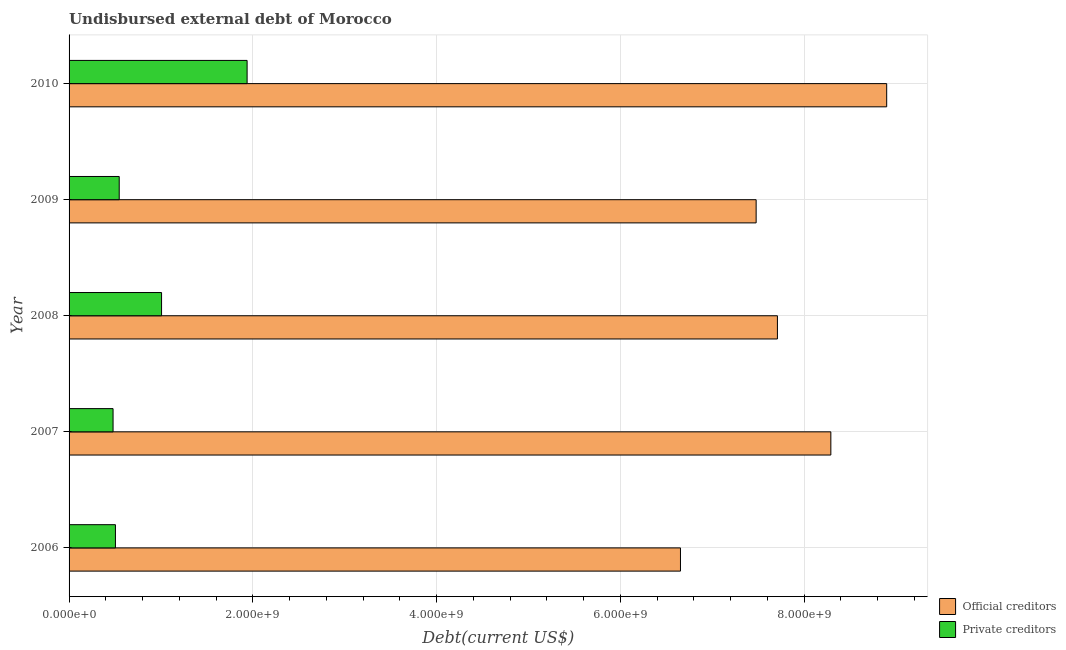Are the number of bars per tick equal to the number of legend labels?
Provide a short and direct response. Yes. How many bars are there on the 3rd tick from the bottom?
Offer a very short reply. 2. What is the label of the 5th group of bars from the top?
Offer a terse response. 2006. What is the undisbursed external debt of private creditors in 2009?
Offer a very short reply. 5.46e+08. Across all years, what is the maximum undisbursed external debt of private creditors?
Ensure brevity in your answer.  1.94e+09. Across all years, what is the minimum undisbursed external debt of private creditors?
Your answer should be very brief. 4.79e+08. In which year was the undisbursed external debt of official creditors maximum?
Offer a very short reply. 2010. In which year was the undisbursed external debt of official creditors minimum?
Give a very brief answer. 2006. What is the total undisbursed external debt of private creditors in the graph?
Keep it short and to the point. 4.47e+09. What is the difference between the undisbursed external debt of official creditors in 2007 and that in 2010?
Provide a succinct answer. -6.08e+08. What is the difference between the undisbursed external debt of private creditors in 2009 and the undisbursed external debt of official creditors in 2008?
Give a very brief answer. -7.16e+09. What is the average undisbursed external debt of private creditors per year?
Your answer should be very brief. 8.95e+08. In the year 2010, what is the difference between the undisbursed external debt of official creditors and undisbursed external debt of private creditors?
Offer a very short reply. 6.96e+09. In how many years, is the undisbursed external debt of official creditors greater than 800000000 US$?
Your answer should be compact. 5. What is the ratio of the undisbursed external debt of official creditors in 2007 to that in 2010?
Provide a succinct answer. 0.93. Is the undisbursed external debt of private creditors in 2006 less than that in 2007?
Provide a short and direct response. No. What is the difference between the highest and the second highest undisbursed external debt of private creditors?
Provide a short and direct response. 9.31e+08. What is the difference between the highest and the lowest undisbursed external debt of official creditors?
Keep it short and to the point. 2.24e+09. In how many years, is the undisbursed external debt of official creditors greater than the average undisbursed external debt of official creditors taken over all years?
Your response must be concise. 2. Is the sum of the undisbursed external debt of private creditors in 2007 and 2008 greater than the maximum undisbursed external debt of official creditors across all years?
Provide a succinct answer. No. What does the 2nd bar from the top in 2007 represents?
Give a very brief answer. Official creditors. What does the 1st bar from the bottom in 2009 represents?
Your answer should be very brief. Official creditors. How many bars are there?
Provide a succinct answer. 10. How many years are there in the graph?
Make the answer very short. 5. Does the graph contain any zero values?
Provide a succinct answer. No. Does the graph contain grids?
Your answer should be compact. Yes. How many legend labels are there?
Provide a succinct answer. 2. How are the legend labels stacked?
Provide a succinct answer. Vertical. What is the title of the graph?
Keep it short and to the point. Undisbursed external debt of Morocco. Does "Official aid received" appear as one of the legend labels in the graph?
Your answer should be very brief. No. What is the label or title of the X-axis?
Provide a short and direct response. Debt(current US$). What is the Debt(current US$) in Official creditors in 2006?
Provide a succinct answer. 6.65e+09. What is the Debt(current US$) in Private creditors in 2006?
Offer a terse response. 5.05e+08. What is the Debt(current US$) in Official creditors in 2007?
Provide a short and direct response. 8.29e+09. What is the Debt(current US$) of Private creditors in 2007?
Make the answer very short. 4.79e+08. What is the Debt(current US$) in Official creditors in 2008?
Offer a very short reply. 7.71e+09. What is the Debt(current US$) in Private creditors in 2008?
Your answer should be compact. 1.01e+09. What is the Debt(current US$) of Official creditors in 2009?
Your answer should be very brief. 7.48e+09. What is the Debt(current US$) of Private creditors in 2009?
Provide a succinct answer. 5.46e+08. What is the Debt(current US$) of Official creditors in 2010?
Your answer should be very brief. 8.90e+09. What is the Debt(current US$) of Private creditors in 2010?
Offer a terse response. 1.94e+09. Across all years, what is the maximum Debt(current US$) in Official creditors?
Give a very brief answer. 8.90e+09. Across all years, what is the maximum Debt(current US$) of Private creditors?
Ensure brevity in your answer.  1.94e+09. Across all years, what is the minimum Debt(current US$) in Official creditors?
Keep it short and to the point. 6.65e+09. Across all years, what is the minimum Debt(current US$) of Private creditors?
Give a very brief answer. 4.79e+08. What is the total Debt(current US$) in Official creditors in the graph?
Keep it short and to the point. 3.90e+1. What is the total Debt(current US$) in Private creditors in the graph?
Give a very brief answer. 4.47e+09. What is the difference between the Debt(current US$) of Official creditors in 2006 and that in 2007?
Offer a very short reply. -1.64e+09. What is the difference between the Debt(current US$) of Private creditors in 2006 and that in 2007?
Your answer should be very brief. 2.58e+07. What is the difference between the Debt(current US$) in Official creditors in 2006 and that in 2008?
Ensure brevity in your answer.  -1.06e+09. What is the difference between the Debt(current US$) of Private creditors in 2006 and that in 2008?
Your answer should be very brief. -5.02e+08. What is the difference between the Debt(current US$) of Official creditors in 2006 and that in 2009?
Offer a terse response. -8.24e+08. What is the difference between the Debt(current US$) of Private creditors in 2006 and that in 2009?
Offer a very short reply. -4.12e+07. What is the difference between the Debt(current US$) in Official creditors in 2006 and that in 2010?
Your answer should be very brief. -2.24e+09. What is the difference between the Debt(current US$) of Private creditors in 2006 and that in 2010?
Offer a terse response. -1.43e+09. What is the difference between the Debt(current US$) in Official creditors in 2007 and that in 2008?
Your answer should be very brief. 5.82e+08. What is the difference between the Debt(current US$) in Private creditors in 2007 and that in 2008?
Make the answer very short. -5.28e+08. What is the difference between the Debt(current US$) in Official creditors in 2007 and that in 2009?
Keep it short and to the point. 8.13e+08. What is the difference between the Debt(current US$) of Private creditors in 2007 and that in 2009?
Ensure brevity in your answer.  -6.70e+07. What is the difference between the Debt(current US$) of Official creditors in 2007 and that in 2010?
Your response must be concise. -6.08e+08. What is the difference between the Debt(current US$) in Private creditors in 2007 and that in 2010?
Offer a terse response. -1.46e+09. What is the difference between the Debt(current US$) in Official creditors in 2008 and that in 2009?
Provide a succinct answer. 2.31e+08. What is the difference between the Debt(current US$) in Private creditors in 2008 and that in 2009?
Offer a very short reply. 4.61e+08. What is the difference between the Debt(current US$) of Official creditors in 2008 and that in 2010?
Ensure brevity in your answer.  -1.19e+09. What is the difference between the Debt(current US$) of Private creditors in 2008 and that in 2010?
Provide a succinct answer. -9.31e+08. What is the difference between the Debt(current US$) in Official creditors in 2009 and that in 2010?
Your answer should be very brief. -1.42e+09. What is the difference between the Debt(current US$) of Private creditors in 2009 and that in 2010?
Offer a terse response. -1.39e+09. What is the difference between the Debt(current US$) of Official creditors in 2006 and the Debt(current US$) of Private creditors in 2007?
Your response must be concise. 6.18e+09. What is the difference between the Debt(current US$) in Official creditors in 2006 and the Debt(current US$) in Private creditors in 2008?
Offer a terse response. 5.65e+09. What is the difference between the Debt(current US$) of Official creditors in 2006 and the Debt(current US$) of Private creditors in 2009?
Keep it short and to the point. 6.11e+09. What is the difference between the Debt(current US$) in Official creditors in 2006 and the Debt(current US$) in Private creditors in 2010?
Give a very brief answer. 4.72e+09. What is the difference between the Debt(current US$) in Official creditors in 2007 and the Debt(current US$) in Private creditors in 2008?
Ensure brevity in your answer.  7.28e+09. What is the difference between the Debt(current US$) in Official creditors in 2007 and the Debt(current US$) in Private creditors in 2009?
Your answer should be very brief. 7.75e+09. What is the difference between the Debt(current US$) of Official creditors in 2007 and the Debt(current US$) of Private creditors in 2010?
Offer a terse response. 6.35e+09. What is the difference between the Debt(current US$) of Official creditors in 2008 and the Debt(current US$) of Private creditors in 2009?
Offer a very short reply. 7.16e+09. What is the difference between the Debt(current US$) of Official creditors in 2008 and the Debt(current US$) of Private creditors in 2010?
Provide a short and direct response. 5.77e+09. What is the difference between the Debt(current US$) in Official creditors in 2009 and the Debt(current US$) in Private creditors in 2010?
Provide a short and direct response. 5.54e+09. What is the average Debt(current US$) in Official creditors per year?
Offer a terse response. 7.81e+09. What is the average Debt(current US$) of Private creditors per year?
Your answer should be compact. 8.95e+08. In the year 2006, what is the difference between the Debt(current US$) of Official creditors and Debt(current US$) of Private creditors?
Provide a succinct answer. 6.15e+09. In the year 2007, what is the difference between the Debt(current US$) of Official creditors and Debt(current US$) of Private creditors?
Provide a succinct answer. 7.81e+09. In the year 2008, what is the difference between the Debt(current US$) of Official creditors and Debt(current US$) of Private creditors?
Keep it short and to the point. 6.70e+09. In the year 2009, what is the difference between the Debt(current US$) of Official creditors and Debt(current US$) of Private creditors?
Provide a short and direct response. 6.93e+09. In the year 2010, what is the difference between the Debt(current US$) of Official creditors and Debt(current US$) of Private creditors?
Keep it short and to the point. 6.96e+09. What is the ratio of the Debt(current US$) in Official creditors in 2006 to that in 2007?
Your answer should be very brief. 0.8. What is the ratio of the Debt(current US$) in Private creditors in 2006 to that in 2007?
Offer a terse response. 1.05. What is the ratio of the Debt(current US$) in Official creditors in 2006 to that in 2008?
Provide a short and direct response. 0.86. What is the ratio of the Debt(current US$) of Private creditors in 2006 to that in 2008?
Offer a terse response. 0.5. What is the ratio of the Debt(current US$) in Official creditors in 2006 to that in 2009?
Provide a short and direct response. 0.89. What is the ratio of the Debt(current US$) of Private creditors in 2006 to that in 2009?
Provide a succinct answer. 0.92. What is the ratio of the Debt(current US$) in Official creditors in 2006 to that in 2010?
Make the answer very short. 0.75. What is the ratio of the Debt(current US$) of Private creditors in 2006 to that in 2010?
Provide a succinct answer. 0.26. What is the ratio of the Debt(current US$) in Official creditors in 2007 to that in 2008?
Give a very brief answer. 1.08. What is the ratio of the Debt(current US$) of Private creditors in 2007 to that in 2008?
Keep it short and to the point. 0.48. What is the ratio of the Debt(current US$) in Official creditors in 2007 to that in 2009?
Keep it short and to the point. 1.11. What is the ratio of the Debt(current US$) in Private creditors in 2007 to that in 2009?
Offer a very short reply. 0.88. What is the ratio of the Debt(current US$) in Official creditors in 2007 to that in 2010?
Your answer should be compact. 0.93. What is the ratio of the Debt(current US$) of Private creditors in 2007 to that in 2010?
Offer a terse response. 0.25. What is the ratio of the Debt(current US$) of Official creditors in 2008 to that in 2009?
Provide a succinct answer. 1.03. What is the ratio of the Debt(current US$) of Private creditors in 2008 to that in 2009?
Offer a very short reply. 1.84. What is the ratio of the Debt(current US$) in Official creditors in 2008 to that in 2010?
Keep it short and to the point. 0.87. What is the ratio of the Debt(current US$) of Private creditors in 2008 to that in 2010?
Offer a very short reply. 0.52. What is the ratio of the Debt(current US$) of Official creditors in 2009 to that in 2010?
Make the answer very short. 0.84. What is the ratio of the Debt(current US$) in Private creditors in 2009 to that in 2010?
Offer a very short reply. 0.28. What is the difference between the highest and the second highest Debt(current US$) in Official creditors?
Give a very brief answer. 6.08e+08. What is the difference between the highest and the second highest Debt(current US$) in Private creditors?
Offer a very short reply. 9.31e+08. What is the difference between the highest and the lowest Debt(current US$) in Official creditors?
Ensure brevity in your answer.  2.24e+09. What is the difference between the highest and the lowest Debt(current US$) of Private creditors?
Your answer should be compact. 1.46e+09. 